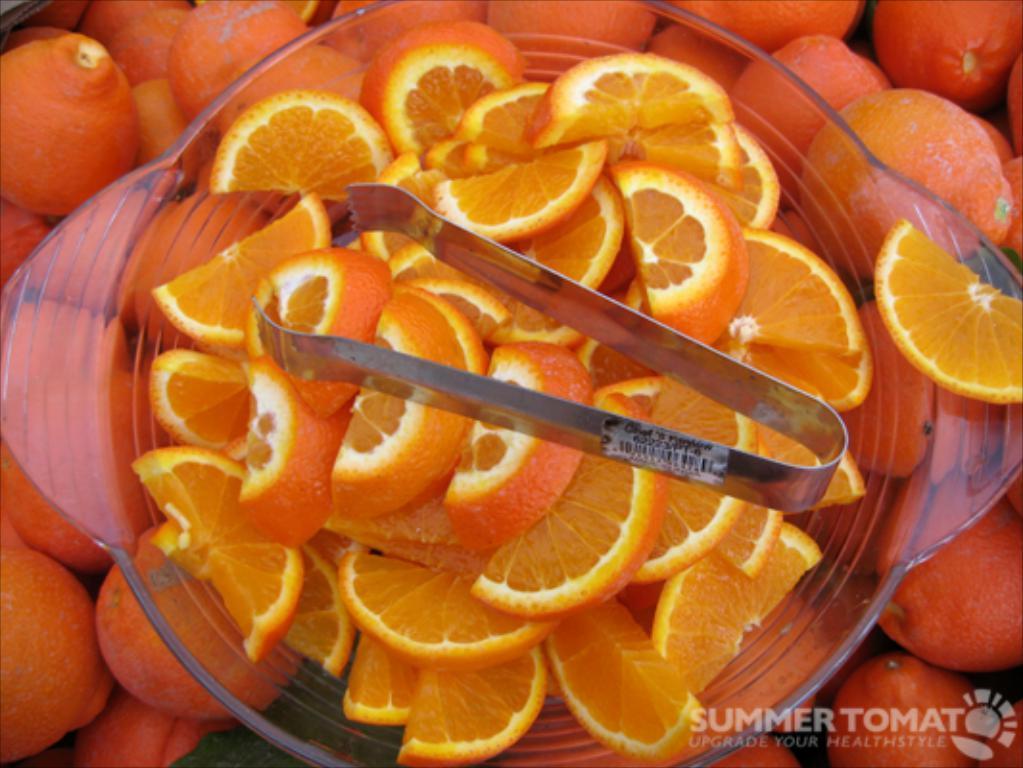Please provide a concise description of this image. In this image we can see orange slices and a holder in the bowl on the oranges and at the bottom corner on the right side we can see a water mark on the image. 